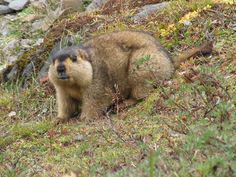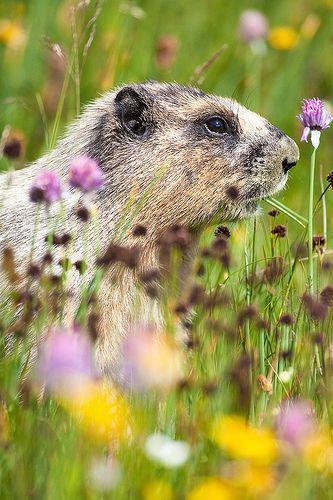The first image is the image on the left, the second image is the image on the right. Considering the images on both sides, is "At least one image features a rodent-type animal standing upright." valid? Answer yes or no. No. 